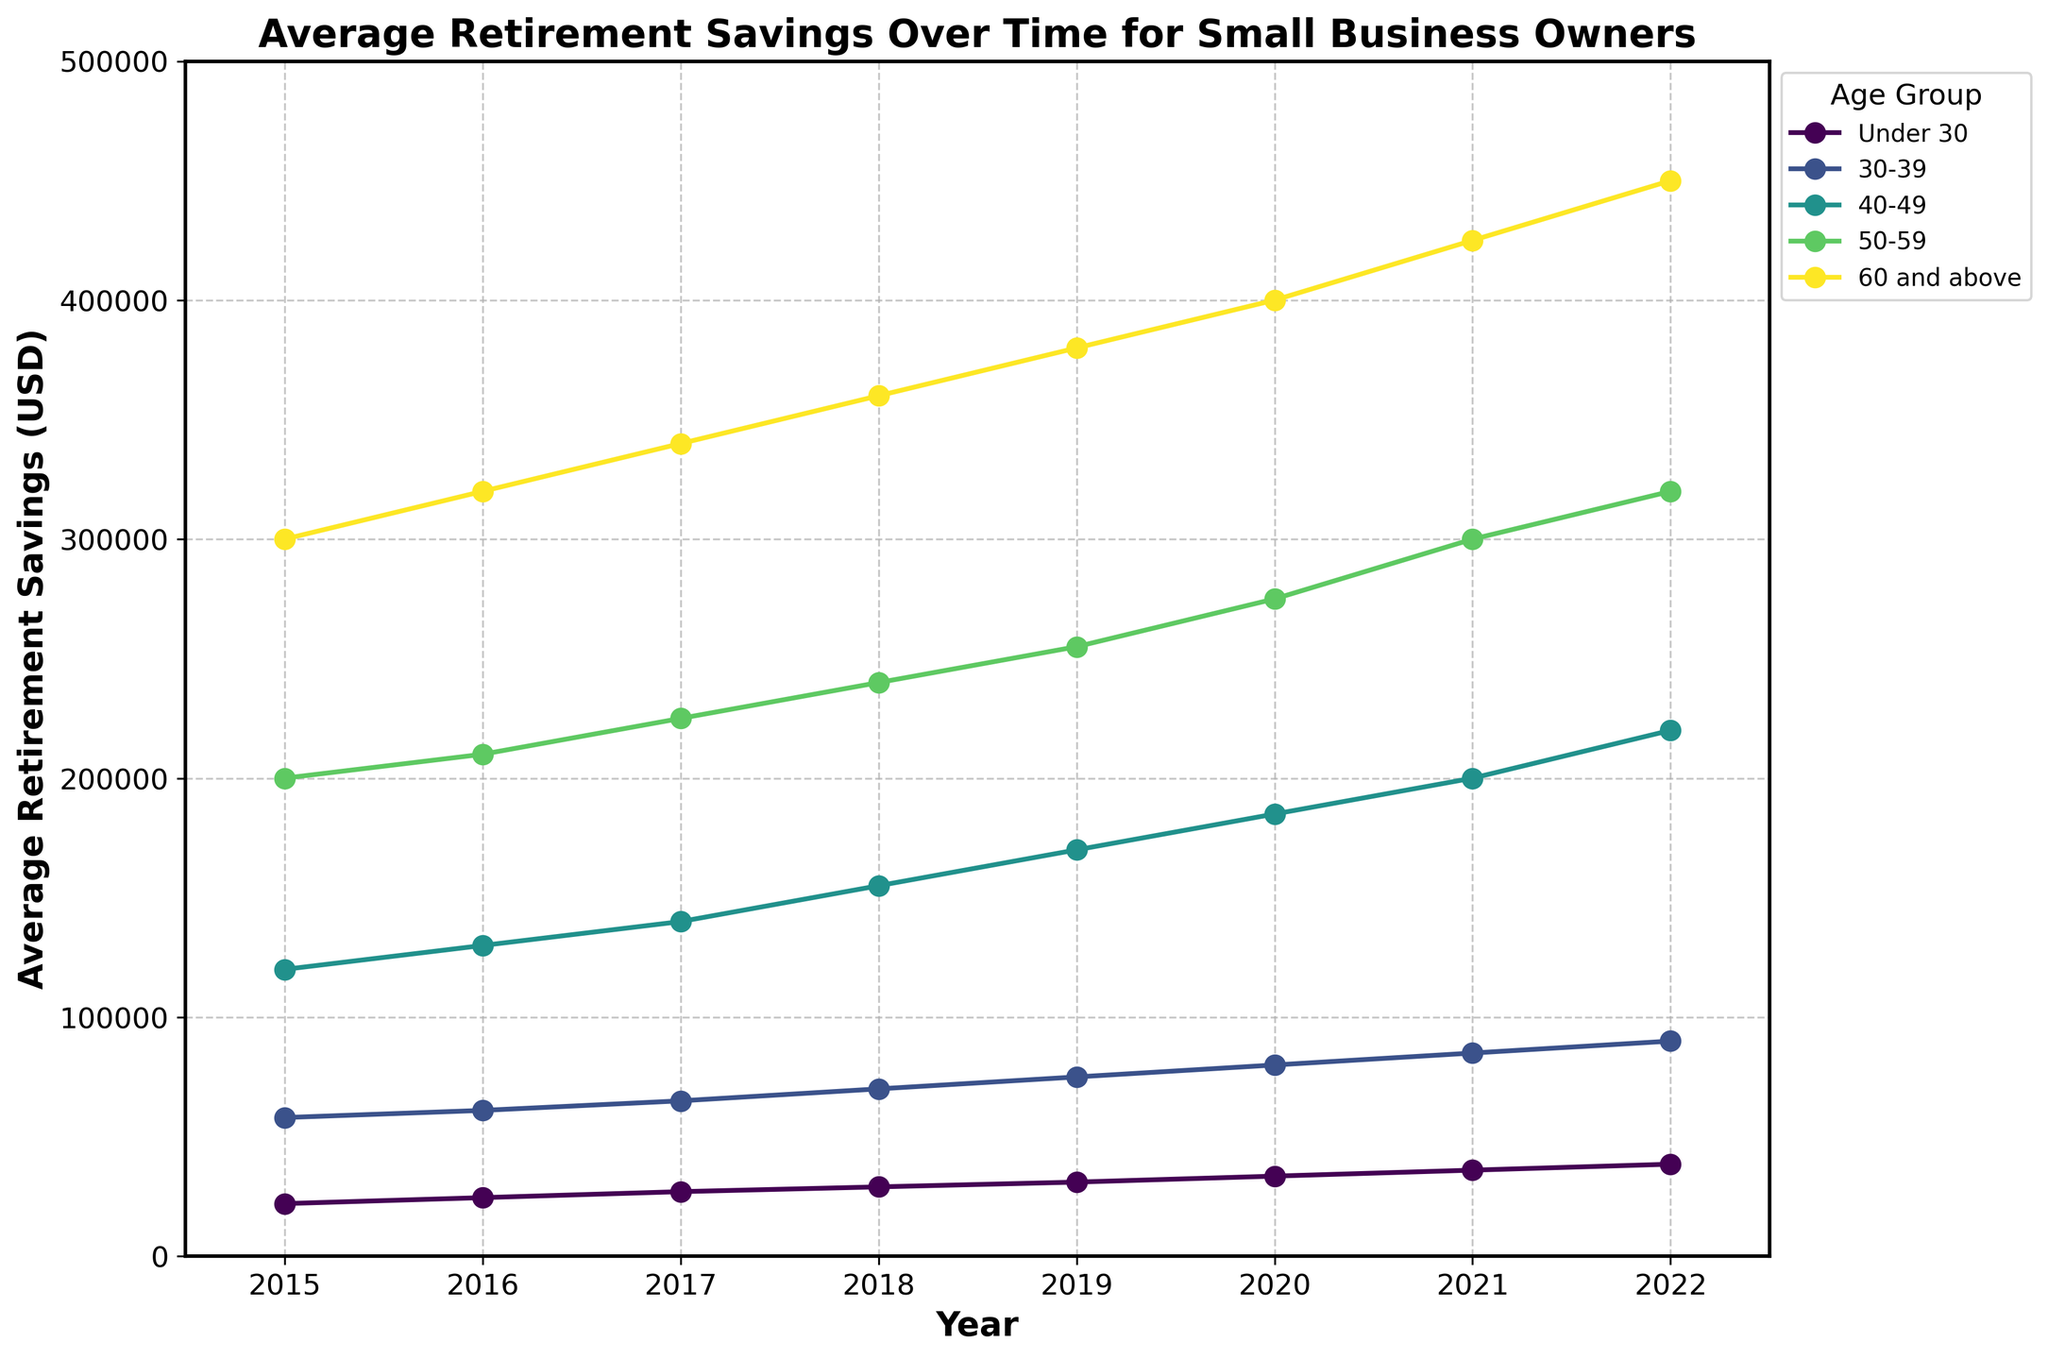what is the title of the figure? The title is typically located at the top of the figure and is meant to summarize its main topic. Here, it should state the main subject of the plot.
Answer: Average Retirement Savings Over Time for Small Business Owners What is the average retirement savings for the 'Under 30' age group in 2019? Locate the 'Under 30' age group and follow its data point to the year 2019. The corresponding value is the answer.
Answer: 31,000 USD In which year did the '60 and above' age group reach an average retirement savings of 400,000 USD? Identify the data points for the '60 and above' age group, then check the year associated with the value of 400,000 USD.
Answer: 2020 Which age group had the highest average retirement savings in 2021? Compare the average retirement savings of all age groups in the year 2021 and identify the group with the highest value.
Answer: 60 and above What was the increase in average retirement savings for the '50-59' age group from 2015 to 2022? Calculate the difference between the values for the '50-59' age group in 2015 and 2022.
Answer: 120,000 USD Between 2018 and 2019, which age group had the smallest increase in average retirement savings? Calculate the difference in average retirement savings for each age group between 2018 and 2019. Identify the smallest increase.
Answer: Under 30 What is the average value of retirement savings across all age groups in 2017? Sum the average retirement savings of all age groups in 2017 and divide by the number of age groups (which is 5).
Answer: 206,500 USD In which year did the '30-39' age group experience the highest increase in average retirement savings compared to the previous year? Calculate the year-over-year increase for the '30-39' age group and identify the year with the highest increase.
Answer: 2019 Are there any age groups whose average retirement savings plateaued at any point between 2015 and 2022? Look for any age group whose average retirement savings remained constant for at least two consecutive years.
Answer: No 